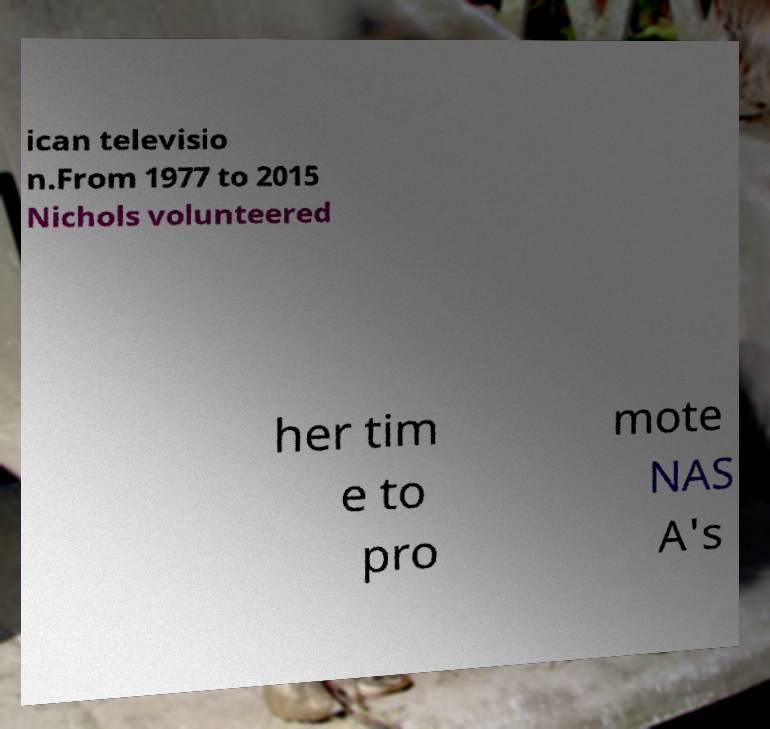Please identify and transcribe the text found in this image. ican televisio n.From 1977 to 2015 Nichols volunteered her tim e to pro mote NAS A's 